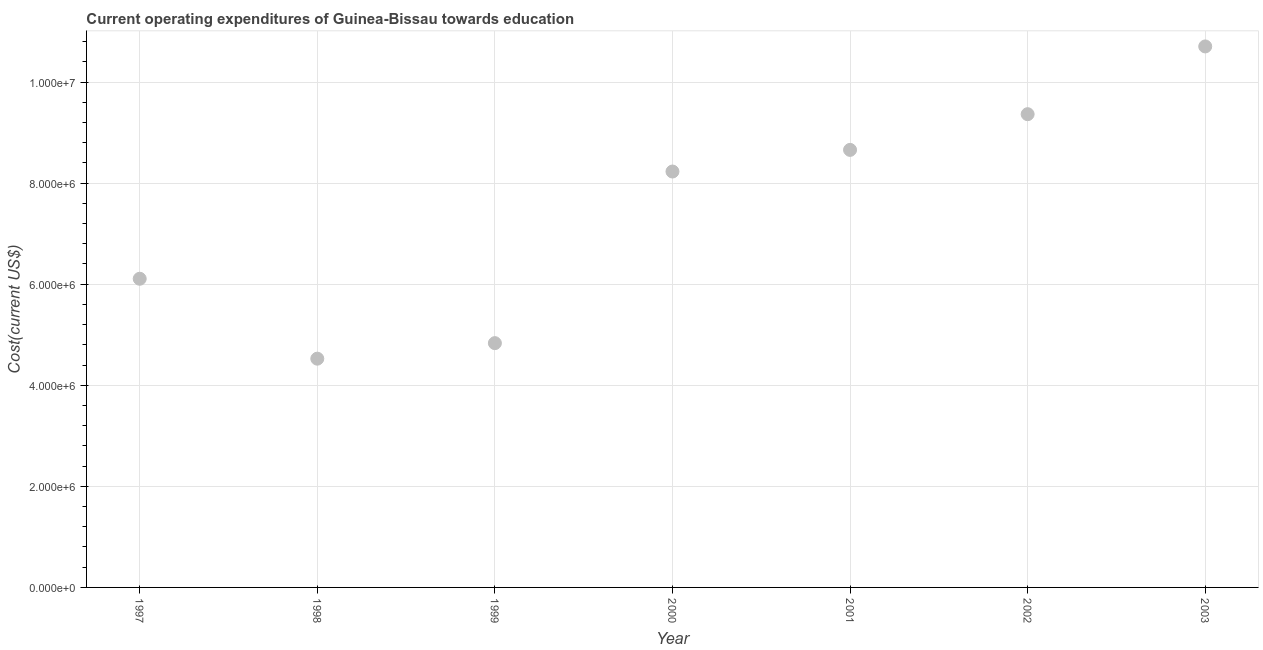What is the education expenditure in 1999?
Ensure brevity in your answer.  4.83e+06. Across all years, what is the maximum education expenditure?
Make the answer very short. 1.07e+07. Across all years, what is the minimum education expenditure?
Give a very brief answer. 4.53e+06. In which year was the education expenditure maximum?
Ensure brevity in your answer.  2003. What is the sum of the education expenditure?
Offer a terse response. 5.24e+07. What is the difference between the education expenditure in 2001 and 2002?
Provide a short and direct response. -7.06e+05. What is the average education expenditure per year?
Your response must be concise. 7.49e+06. What is the median education expenditure?
Offer a very short reply. 8.23e+06. Do a majority of the years between 1998 and 1999 (inclusive) have education expenditure greater than 4400000 US$?
Your response must be concise. Yes. What is the ratio of the education expenditure in 1999 to that in 2001?
Provide a succinct answer. 0.56. Is the difference between the education expenditure in 2000 and 2001 greater than the difference between any two years?
Give a very brief answer. No. What is the difference between the highest and the second highest education expenditure?
Your answer should be compact. 1.34e+06. Is the sum of the education expenditure in 2000 and 2003 greater than the maximum education expenditure across all years?
Your answer should be compact. Yes. What is the difference between the highest and the lowest education expenditure?
Your answer should be compact. 6.18e+06. In how many years, is the education expenditure greater than the average education expenditure taken over all years?
Keep it short and to the point. 4. Does the education expenditure monotonically increase over the years?
Provide a succinct answer. No. How many years are there in the graph?
Keep it short and to the point. 7. Are the values on the major ticks of Y-axis written in scientific E-notation?
Provide a short and direct response. Yes. What is the title of the graph?
Make the answer very short. Current operating expenditures of Guinea-Bissau towards education. What is the label or title of the X-axis?
Your response must be concise. Year. What is the label or title of the Y-axis?
Offer a very short reply. Cost(current US$). What is the Cost(current US$) in 1997?
Keep it short and to the point. 6.11e+06. What is the Cost(current US$) in 1998?
Offer a terse response. 4.53e+06. What is the Cost(current US$) in 1999?
Your response must be concise. 4.83e+06. What is the Cost(current US$) in 2000?
Give a very brief answer. 8.23e+06. What is the Cost(current US$) in 2001?
Your answer should be compact. 8.66e+06. What is the Cost(current US$) in 2002?
Give a very brief answer. 9.36e+06. What is the Cost(current US$) in 2003?
Ensure brevity in your answer.  1.07e+07. What is the difference between the Cost(current US$) in 1997 and 1998?
Your response must be concise. 1.58e+06. What is the difference between the Cost(current US$) in 1997 and 1999?
Provide a short and direct response. 1.27e+06. What is the difference between the Cost(current US$) in 1997 and 2000?
Your answer should be very brief. -2.12e+06. What is the difference between the Cost(current US$) in 1997 and 2001?
Provide a succinct answer. -2.55e+06. What is the difference between the Cost(current US$) in 1997 and 2002?
Give a very brief answer. -3.26e+06. What is the difference between the Cost(current US$) in 1997 and 2003?
Make the answer very short. -4.60e+06. What is the difference between the Cost(current US$) in 1998 and 1999?
Your response must be concise. -3.07e+05. What is the difference between the Cost(current US$) in 1998 and 2000?
Ensure brevity in your answer.  -3.70e+06. What is the difference between the Cost(current US$) in 1998 and 2001?
Make the answer very short. -4.13e+06. What is the difference between the Cost(current US$) in 1998 and 2002?
Make the answer very short. -4.84e+06. What is the difference between the Cost(current US$) in 1998 and 2003?
Make the answer very short. -6.18e+06. What is the difference between the Cost(current US$) in 1999 and 2000?
Your answer should be very brief. -3.40e+06. What is the difference between the Cost(current US$) in 1999 and 2001?
Your answer should be very brief. -3.82e+06. What is the difference between the Cost(current US$) in 1999 and 2002?
Provide a succinct answer. -4.53e+06. What is the difference between the Cost(current US$) in 1999 and 2003?
Offer a terse response. -5.87e+06. What is the difference between the Cost(current US$) in 2000 and 2001?
Ensure brevity in your answer.  -4.28e+05. What is the difference between the Cost(current US$) in 2000 and 2002?
Offer a very short reply. -1.13e+06. What is the difference between the Cost(current US$) in 2000 and 2003?
Offer a very short reply. -2.47e+06. What is the difference between the Cost(current US$) in 2001 and 2002?
Make the answer very short. -7.06e+05. What is the difference between the Cost(current US$) in 2001 and 2003?
Give a very brief answer. -2.05e+06. What is the difference between the Cost(current US$) in 2002 and 2003?
Your answer should be very brief. -1.34e+06. What is the ratio of the Cost(current US$) in 1997 to that in 1998?
Offer a very short reply. 1.35. What is the ratio of the Cost(current US$) in 1997 to that in 1999?
Provide a succinct answer. 1.26. What is the ratio of the Cost(current US$) in 1997 to that in 2000?
Your answer should be compact. 0.74. What is the ratio of the Cost(current US$) in 1997 to that in 2001?
Your answer should be compact. 0.7. What is the ratio of the Cost(current US$) in 1997 to that in 2002?
Make the answer very short. 0.65. What is the ratio of the Cost(current US$) in 1997 to that in 2003?
Offer a very short reply. 0.57. What is the ratio of the Cost(current US$) in 1998 to that in 1999?
Offer a terse response. 0.94. What is the ratio of the Cost(current US$) in 1998 to that in 2000?
Ensure brevity in your answer.  0.55. What is the ratio of the Cost(current US$) in 1998 to that in 2001?
Your response must be concise. 0.52. What is the ratio of the Cost(current US$) in 1998 to that in 2002?
Make the answer very short. 0.48. What is the ratio of the Cost(current US$) in 1998 to that in 2003?
Your answer should be very brief. 0.42. What is the ratio of the Cost(current US$) in 1999 to that in 2000?
Your answer should be compact. 0.59. What is the ratio of the Cost(current US$) in 1999 to that in 2001?
Keep it short and to the point. 0.56. What is the ratio of the Cost(current US$) in 1999 to that in 2002?
Your answer should be very brief. 0.52. What is the ratio of the Cost(current US$) in 1999 to that in 2003?
Keep it short and to the point. 0.45. What is the ratio of the Cost(current US$) in 2000 to that in 2001?
Your answer should be very brief. 0.95. What is the ratio of the Cost(current US$) in 2000 to that in 2002?
Give a very brief answer. 0.88. What is the ratio of the Cost(current US$) in 2000 to that in 2003?
Your answer should be very brief. 0.77. What is the ratio of the Cost(current US$) in 2001 to that in 2002?
Your response must be concise. 0.93. What is the ratio of the Cost(current US$) in 2001 to that in 2003?
Your answer should be compact. 0.81. 